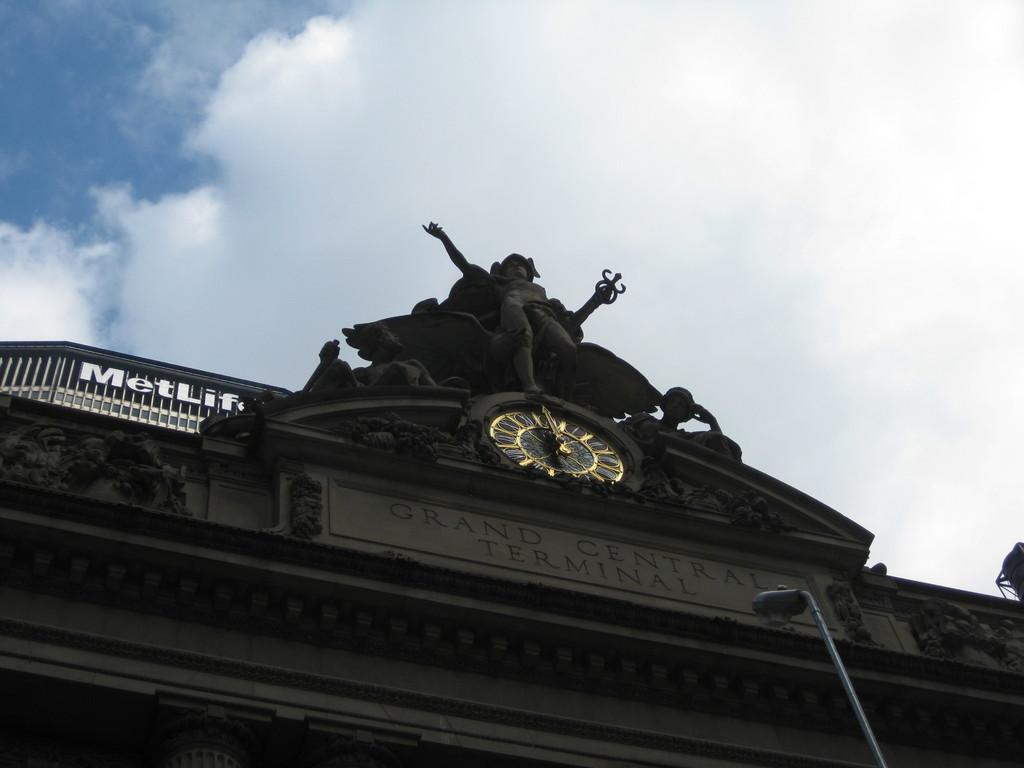<image>
Provide a brief description of the given image. Looking up at Grand Central Terminal with the MetLife building behind. 